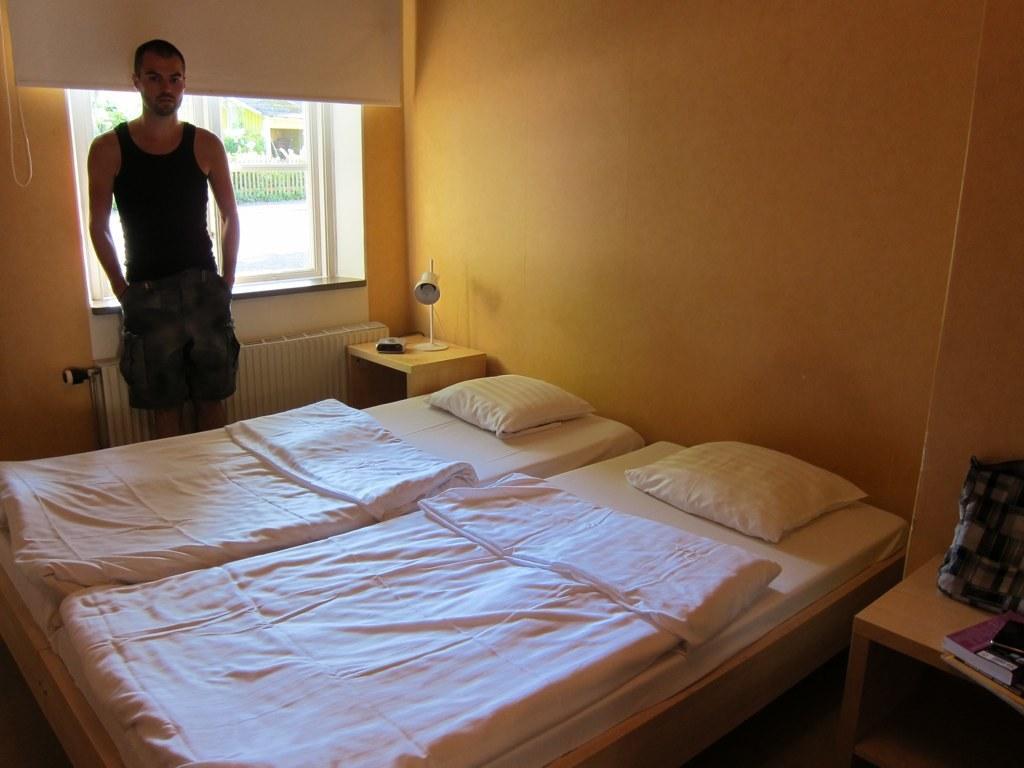Please provide a concise description of this image. This picture is of inside. On the right there is table on the top of which there is a bag and a book is placed. In the center there is a bed on the top which there is a pillow and a blanket is placed and there is a side lamp placed on the side table. On the left there is a Man standing, behind him there is a window and a window blind and through the window we can see the ground and a outside view. 